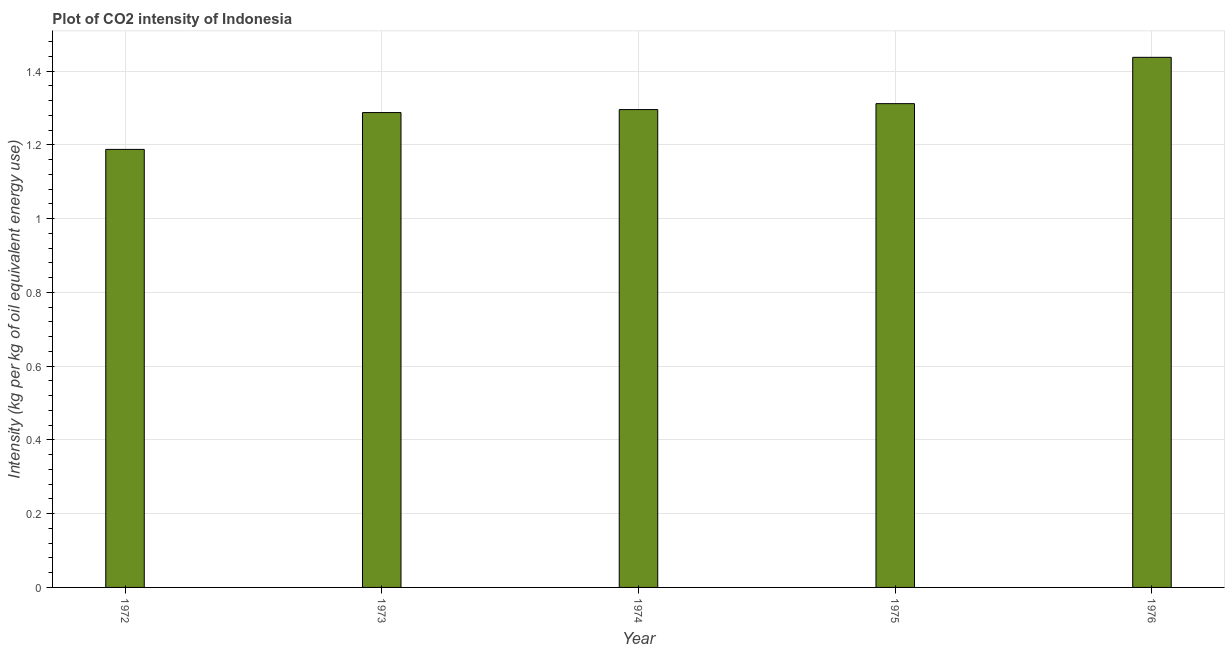Does the graph contain grids?
Your answer should be very brief. Yes. What is the title of the graph?
Your answer should be very brief. Plot of CO2 intensity of Indonesia. What is the label or title of the Y-axis?
Make the answer very short. Intensity (kg per kg of oil equivalent energy use). What is the co2 intensity in 1975?
Give a very brief answer. 1.31. Across all years, what is the maximum co2 intensity?
Provide a succinct answer. 1.44. Across all years, what is the minimum co2 intensity?
Your response must be concise. 1.19. In which year was the co2 intensity maximum?
Provide a short and direct response. 1976. What is the sum of the co2 intensity?
Make the answer very short. 6.52. What is the difference between the co2 intensity in 1973 and 1974?
Ensure brevity in your answer.  -0.01. What is the average co2 intensity per year?
Ensure brevity in your answer.  1.3. What is the median co2 intensity?
Make the answer very short. 1.3. Do a majority of the years between 1976 and 1973 (inclusive) have co2 intensity greater than 0.6 kg?
Give a very brief answer. Yes. What is the ratio of the co2 intensity in 1972 to that in 1975?
Your answer should be very brief. 0.91. What is the difference between the highest and the second highest co2 intensity?
Offer a very short reply. 0.13. In how many years, is the co2 intensity greater than the average co2 intensity taken over all years?
Offer a terse response. 2. Are all the bars in the graph horizontal?
Offer a terse response. No. How many years are there in the graph?
Make the answer very short. 5. What is the difference between two consecutive major ticks on the Y-axis?
Your response must be concise. 0.2. Are the values on the major ticks of Y-axis written in scientific E-notation?
Make the answer very short. No. What is the Intensity (kg per kg of oil equivalent energy use) in 1972?
Give a very brief answer. 1.19. What is the Intensity (kg per kg of oil equivalent energy use) of 1973?
Your answer should be compact. 1.29. What is the Intensity (kg per kg of oil equivalent energy use) in 1974?
Your response must be concise. 1.3. What is the Intensity (kg per kg of oil equivalent energy use) of 1975?
Give a very brief answer. 1.31. What is the Intensity (kg per kg of oil equivalent energy use) of 1976?
Offer a very short reply. 1.44. What is the difference between the Intensity (kg per kg of oil equivalent energy use) in 1972 and 1973?
Give a very brief answer. -0.1. What is the difference between the Intensity (kg per kg of oil equivalent energy use) in 1972 and 1974?
Keep it short and to the point. -0.11. What is the difference between the Intensity (kg per kg of oil equivalent energy use) in 1972 and 1975?
Your answer should be compact. -0.12. What is the difference between the Intensity (kg per kg of oil equivalent energy use) in 1972 and 1976?
Provide a succinct answer. -0.25. What is the difference between the Intensity (kg per kg of oil equivalent energy use) in 1973 and 1974?
Provide a succinct answer. -0.01. What is the difference between the Intensity (kg per kg of oil equivalent energy use) in 1973 and 1975?
Ensure brevity in your answer.  -0.02. What is the difference between the Intensity (kg per kg of oil equivalent energy use) in 1973 and 1976?
Offer a very short reply. -0.15. What is the difference between the Intensity (kg per kg of oil equivalent energy use) in 1974 and 1975?
Provide a short and direct response. -0.02. What is the difference between the Intensity (kg per kg of oil equivalent energy use) in 1974 and 1976?
Your response must be concise. -0.14. What is the difference between the Intensity (kg per kg of oil equivalent energy use) in 1975 and 1976?
Your answer should be very brief. -0.13. What is the ratio of the Intensity (kg per kg of oil equivalent energy use) in 1972 to that in 1973?
Provide a short and direct response. 0.92. What is the ratio of the Intensity (kg per kg of oil equivalent energy use) in 1972 to that in 1974?
Make the answer very short. 0.92. What is the ratio of the Intensity (kg per kg of oil equivalent energy use) in 1972 to that in 1975?
Offer a very short reply. 0.91. What is the ratio of the Intensity (kg per kg of oil equivalent energy use) in 1972 to that in 1976?
Make the answer very short. 0.83. What is the ratio of the Intensity (kg per kg of oil equivalent energy use) in 1973 to that in 1975?
Provide a succinct answer. 0.98. What is the ratio of the Intensity (kg per kg of oil equivalent energy use) in 1973 to that in 1976?
Provide a short and direct response. 0.9. What is the ratio of the Intensity (kg per kg of oil equivalent energy use) in 1974 to that in 1976?
Ensure brevity in your answer.  0.9. 